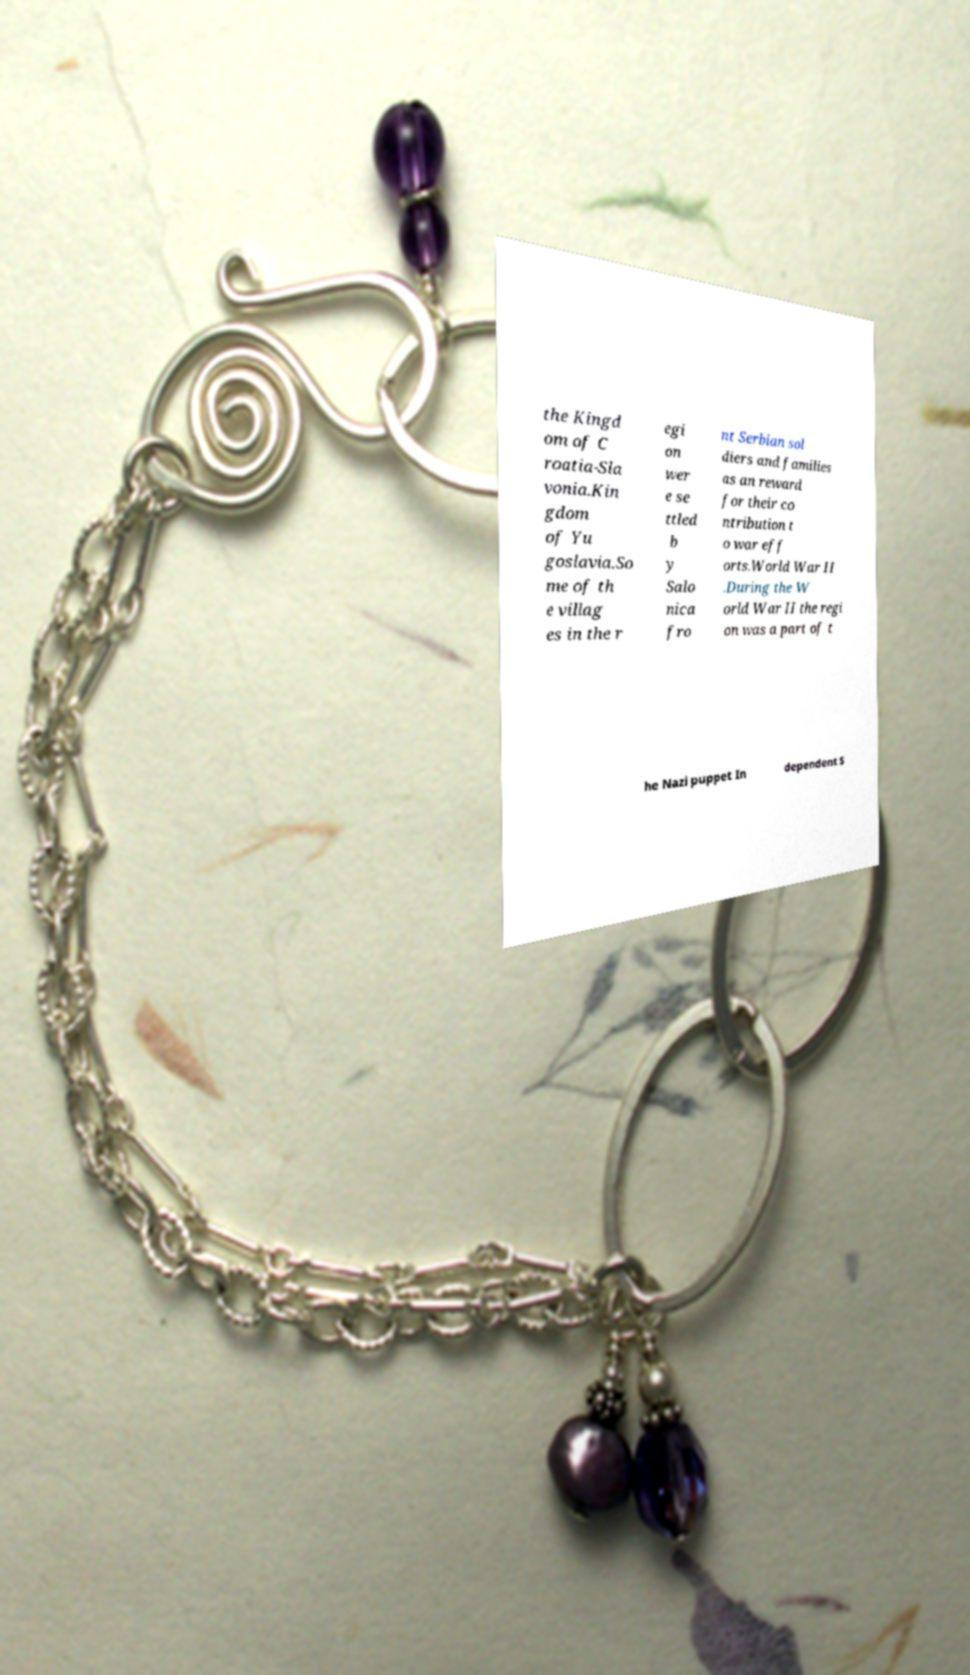Could you assist in decoding the text presented in this image and type it out clearly? the Kingd om of C roatia-Sla vonia.Kin gdom of Yu goslavia.So me of th e villag es in the r egi on wer e se ttled b y Salo nica fro nt Serbian sol diers and families as an reward for their co ntribution t o war eff orts.World War II .During the W orld War II the regi on was a part of t he Nazi puppet In dependent S 